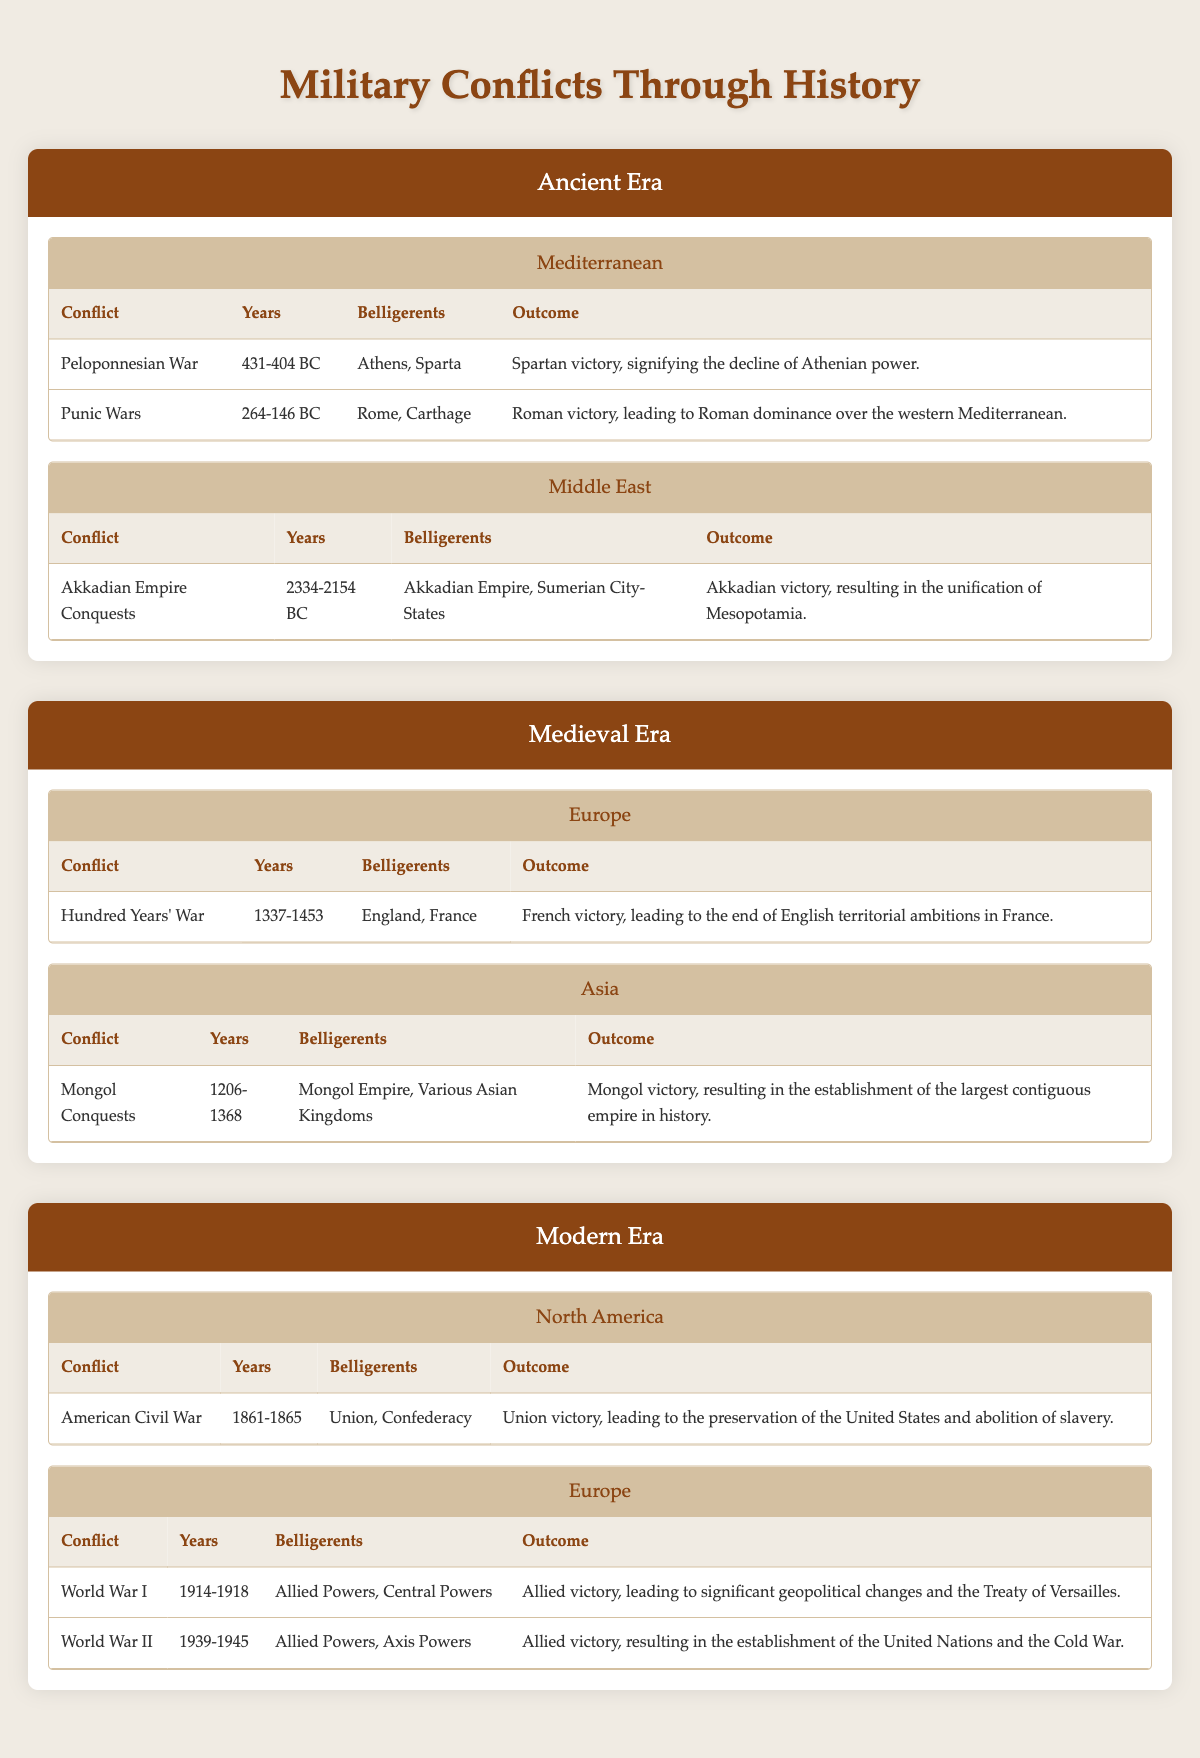What were the years of the Punic Wars? The table lists the years for each conflict under the Ancient Era, specifically in the Mediterranean region. For the Punic Wars, it states "264-146 BC."
Answer: 264-146 BC Which region experienced the Mongol Conquests? The Mongol Conquests occurred in the Asia region as indicated in the Medieval Era section of the table.
Answer: Asia Did the Akkadian Empire win their conquests? The table shows that the Akkadian Empire was victorious in its conquests, which is explicitly stated in the outcome for the Akkadian Empire Conquests.
Answer: Yes How many conflicts occurred in the Modern Era in Europe? The table lists two conflicts in the Modern Era under the Europe region: World War I and World War II. Therefore, counting these provides the answer.
Answer: 2 What was the outcome of the American Civil War and what was its significance? The outcome listed is a Union victory, which is significant as it led to the preservation of the United States and the abolition of slavery.
Answer: Union victory, preservation of the United States, abolition of slavery What is the total number of belligerents involved in the Hundred Years' War and the Punic Wars? The table specifies two belligerents for the Hundred Years' War (England, France) and for the Punic Wars (Rome, Carthage), summing gives a total of four unique belligerents.
Answer: 4 Was the French victory in the Hundred Years' War significant in terms of territorial ambitions? Yes, the table indicates this victory led to the end of English territorial ambitions in France, making it a significant outcome.
Answer: Yes What were the key outcomes of World War I and World War II? The outcomes of both conflicts are mentioned in the table: World War I led to significant geopolitical changes and the Treaty of Versailles, while World War II resulted in the establishment of the United Nations and the Cold War.
Answer: Significant geopolitical changes and the establishment of the United Nations 